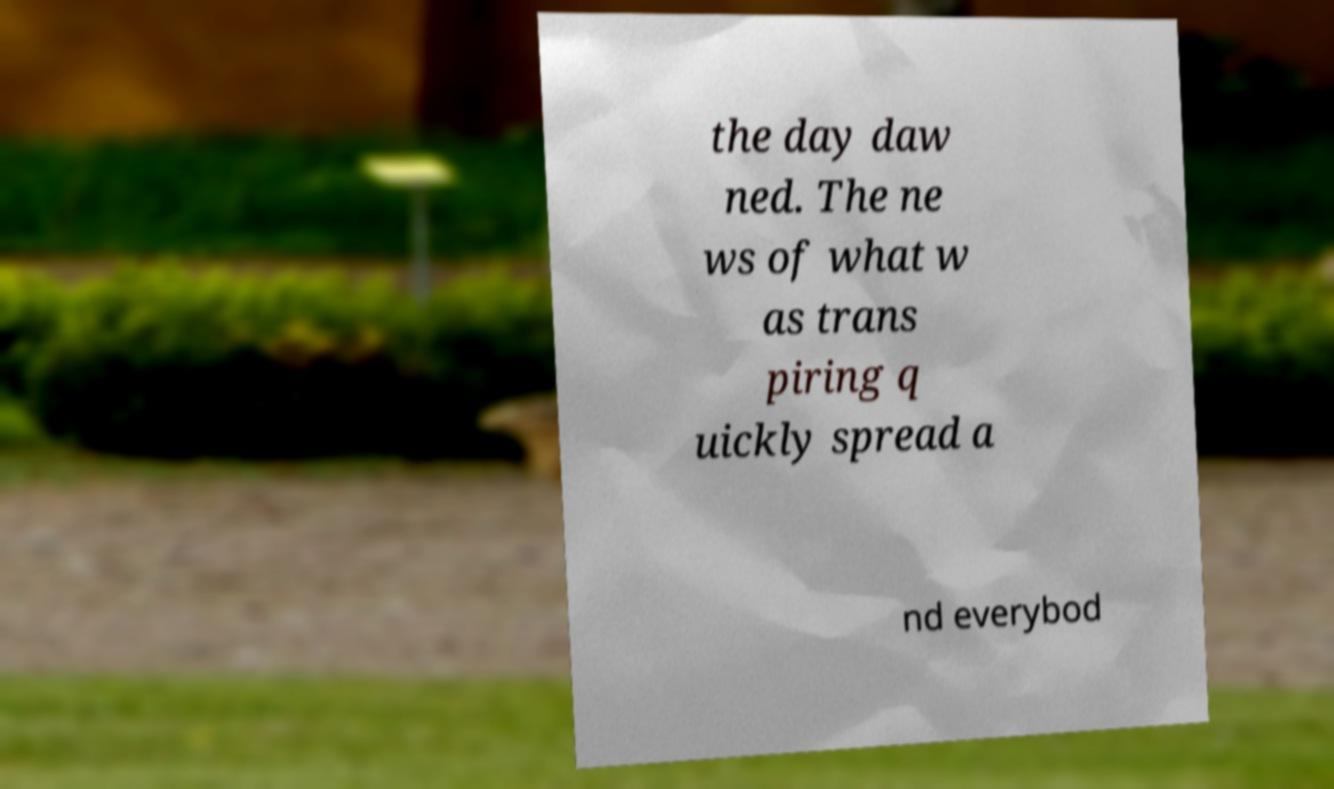What messages or text are displayed in this image? I need them in a readable, typed format. the day daw ned. The ne ws of what w as trans piring q uickly spread a nd everybod 